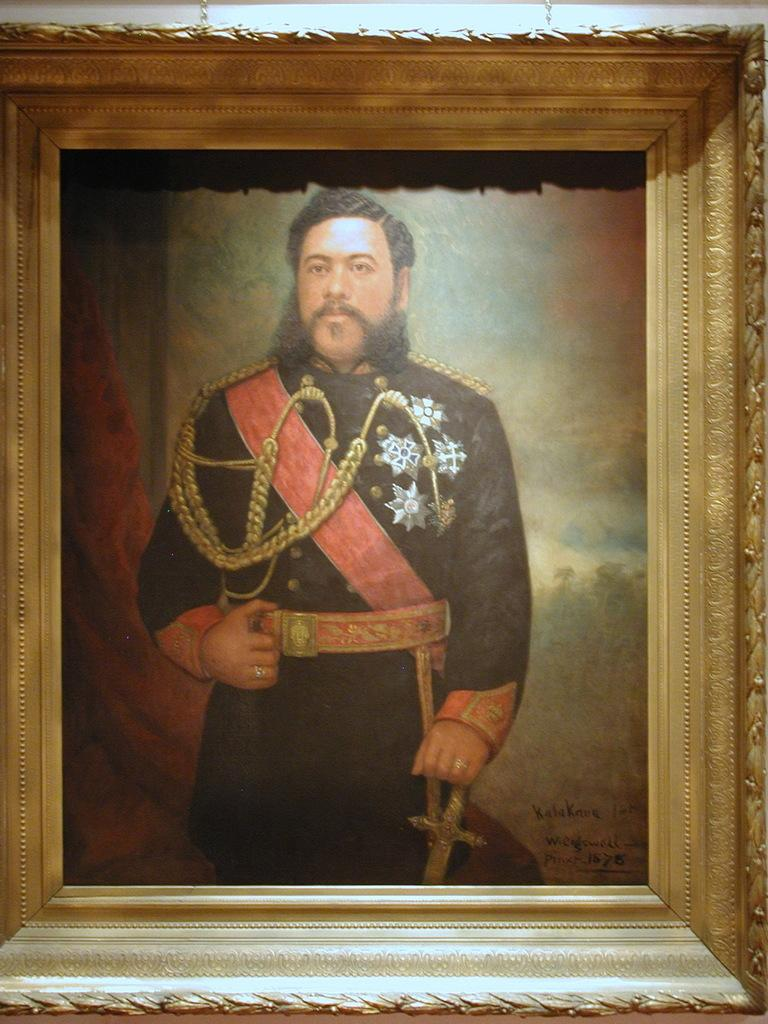What object is present in the image that typically holds a photograph? There is a photo frame in the image. What can be seen inside the photo frame? The photo frame contains a person. What is the person in the photo frame wearing? The person is wearing a black dress. What is the person in the photo frame doing? The person is standing and has one hand on a sword. What is written in the right bottom corner of the image? There is text written in the right bottom corner of the image. How many people are sitting on the army in the image? There is no army present in the image, and therefore no one is sitting on it. 